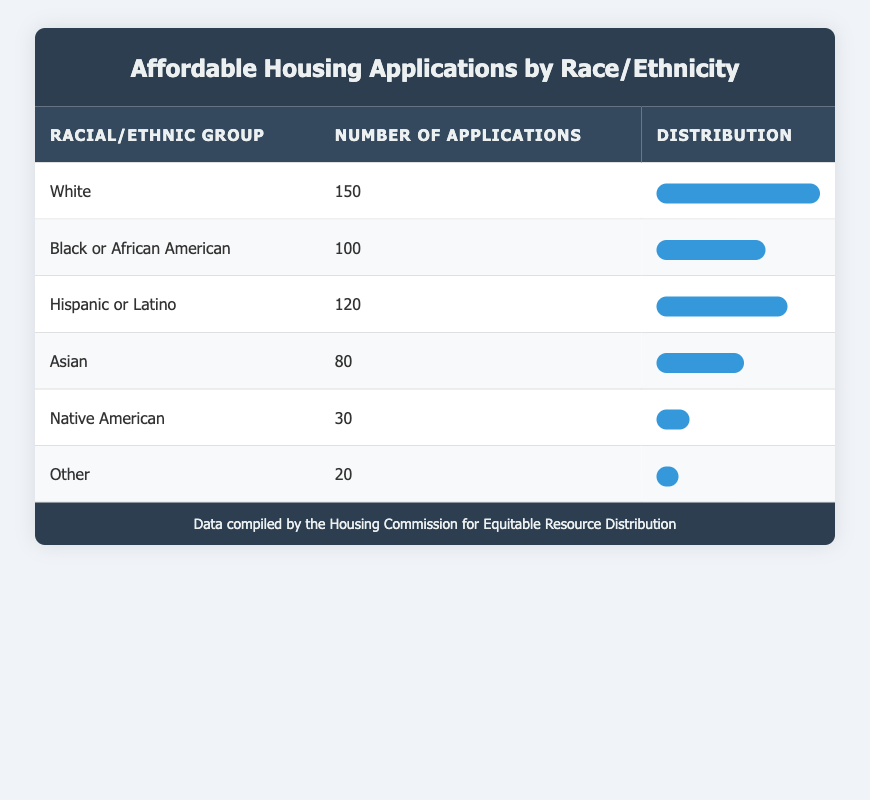What is the total number of applications for affordable housing? To find the total number of applications, we need to add the applications count for each racial/ethnic group: 150 (White) + 100 (Black or African American) + 120 (Hispanic or Latino) + 80 (Asian) + 30 (Native American) + 20 (Other) = 500.
Answer: 500 Which racial/ethnic group submitted the highest number of applications? By examining the table, White has the highest applications count at 150.
Answer: White What percentage of applications came from Hispanic or Latino individuals? The total number of applications is 500. The application count for Hispanic or Latino is 120. To calculate the percentage, we use the formula: (120/500) * 100 = 24%.
Answer: 24% Which groups' application counts are below the average application count? First, we calculate the average number of applications: Total number is 500, and there are 6 groups, so the average is 500/6 ≈ 83.33. The groups with counts below the average are: Asian (80), Native American (30), and Other (20).
Answer: Asian, Native American, Other Is it true that Black or African American individuals submitted more applications than Asian individuals? Black or African American has an applications count of 100, while Asian has a count of 80. Since 100 is greater than 80, this statement is true.
Answer: Yes What is the difference in the number of applications between the highest and lowest groups? The highest group is White with 150 applications, and the lowest group is Other with 20 applications. The difference is calculated as 150 - 20 = 130.
Answer: 130 Which two racial/ethnic groups have the closest application counts? Looking at the application counts, Black or African American (100) and Hispanic or Latino (120) have counts that are close compared to others. The difference between them is 120 - 100 = 20.
Answer: Black or African American and Hispanic or Latino What is the cumulative number of applications for the three groups with the lowest counts? The three groups with the lowest counts are Native American (30), Other (20), and Asian (80). We sum these counts: 30 + 20 + 80 = 130.
Answer: 130 